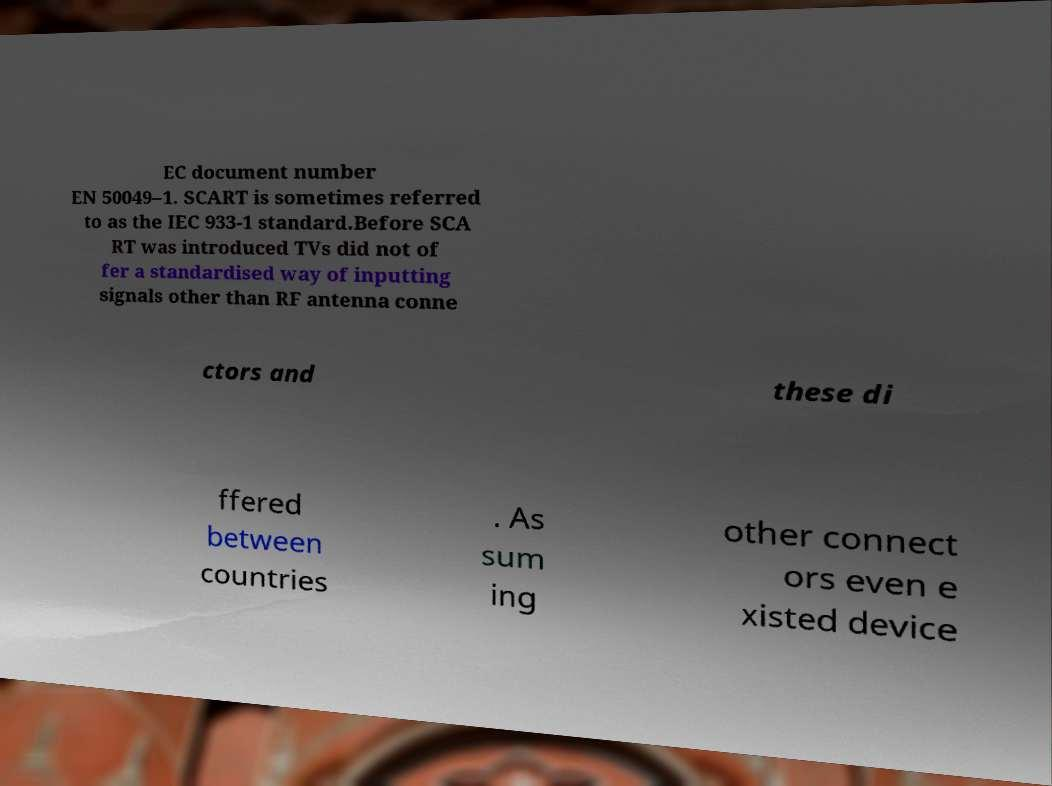Can you accurately transcribe the text from the provided image for me? EC document number EN 50049–1. SCART is sometimes referred to as the IEC 933-1 standard.Before SCA RT was introduced TVs did not of fer a standardised way of inputting signals other than RF antenna conne ctors and these di ffered between countries . As sum ing other connect ors even e xisted device 